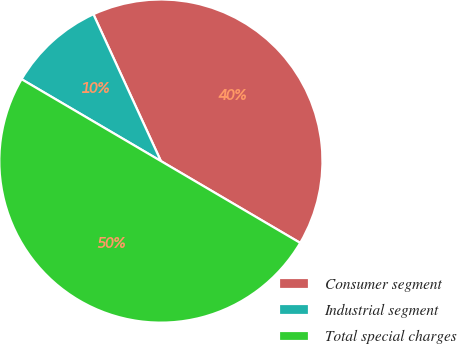Convert chart to OTSL. <chart><loc_0><loc_0><loc_500><loc_500><pie_chart><fcel>Consumer segment<fcel>Industrial segment<fcel>Total special charges<nl><fcel>40.31%<fcel>9.69%<fcel>50.0%<nl></chart> 